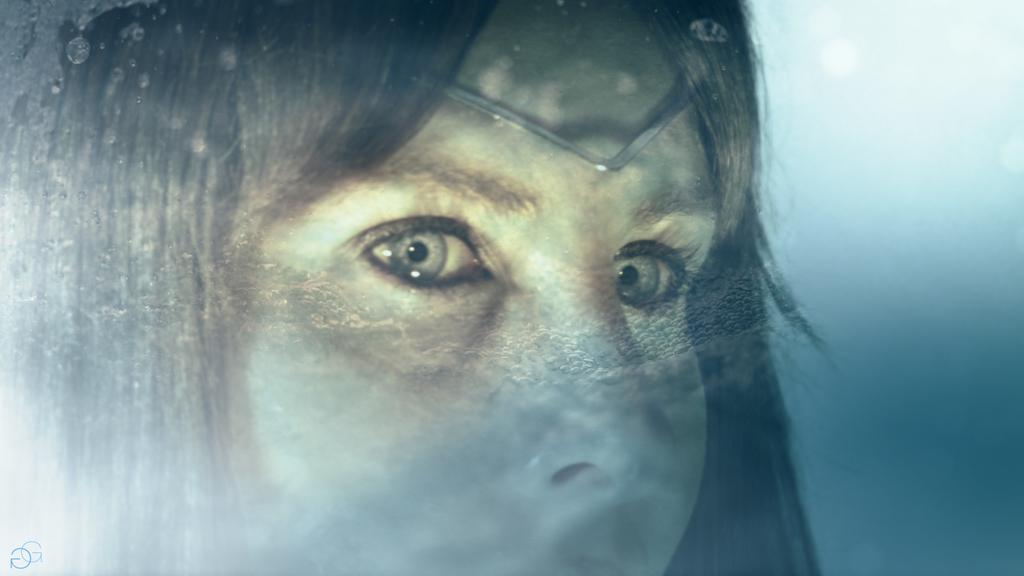Who is the main subject in the image? There is a woman in the image. What color is the background of the image? The background of the image is blue. Are there any additional elements in the image besides the woman? Yes, there are symbols in the bottom left corner of the image. What type of noise can be heard coming from the woman in the image? There is no indication of any noise in the image, so it cannot be determined from the image. 